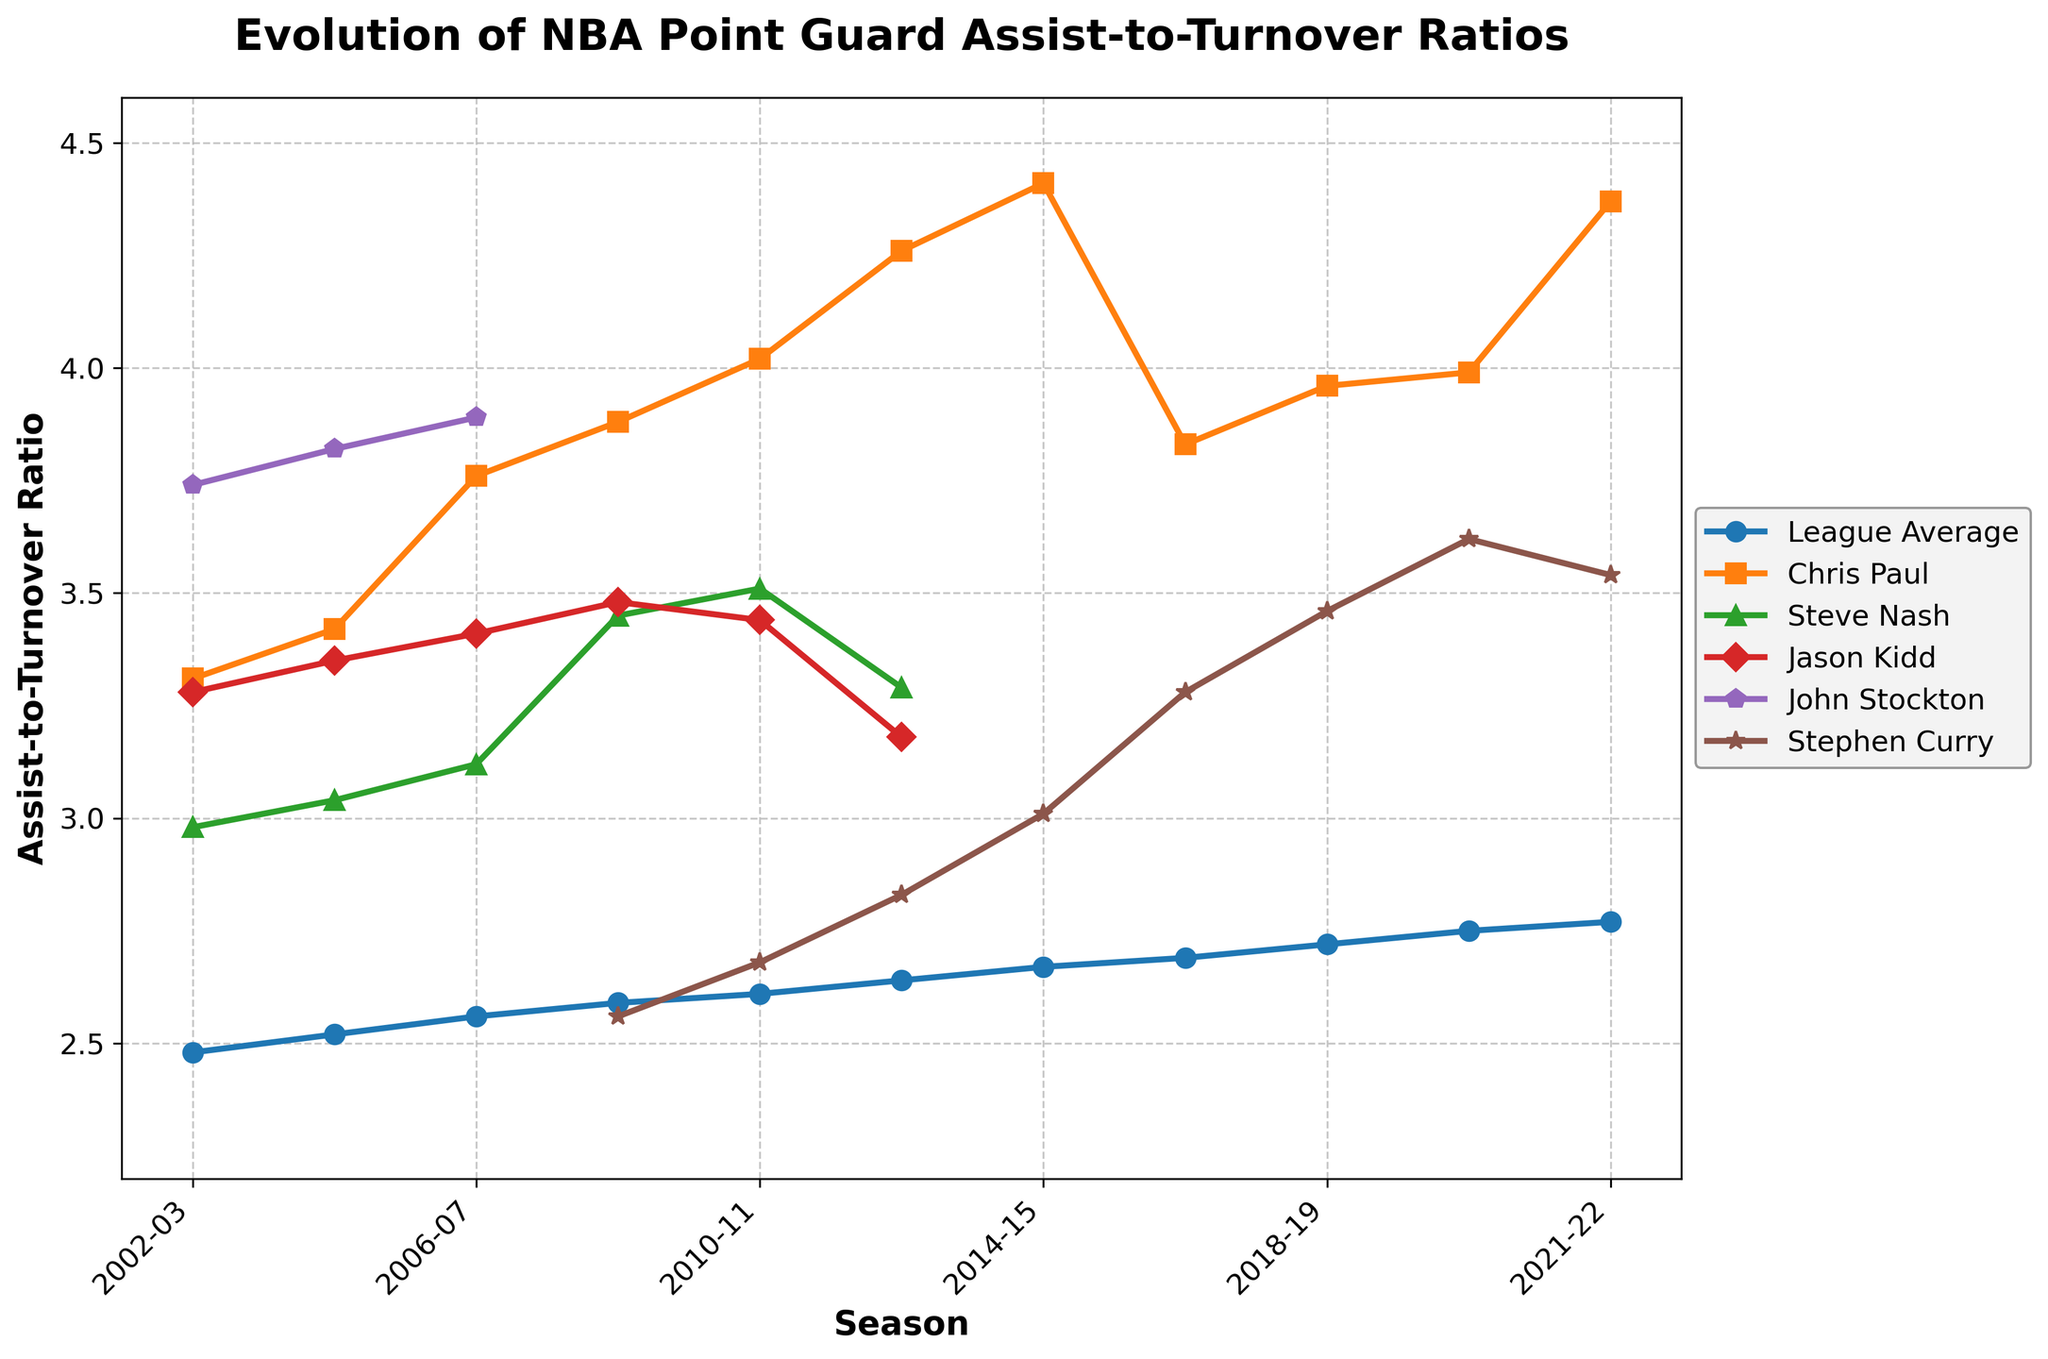What's the average assist-to-turnover ratio for Chris Paul from 2002-03 to 2021-22? The seasons for Chris Paul's data range from 2002-03 to 2021-22. Sum up the assist-to-turnover ratios for these seasons: (3.31 + 3.42 + 3.76 + 3.88 + 4.02 + 4.26 + 4.41 + 3.83 + 3.96 + 3.99 + 4.37) = 43.21. Divide by the number of seasons (11). The average is 43.21/11 = 3.93
Answer: 3.93 Who had the highest assist-to-turnover ratio in the 2006-07 season? In the 2006-07 season, the assist-to-turnover ratios are as follows: League Average: 2.56, Chris Paul: 3.76, Steve Nash: 3.12, Jason Kidd: 3.41, John Stockton: 3.89. The highest value is 3.89 by John Stockton.
Answer: John Stockton How much did the league average assist-to-turnover ratio increase from 2002-03 to 2021-22? Subtract the value for 2002-03 (2.48) from the value for 2021-22 (2.77). The increase is 2.77 - 2.48 = 0.29
Answer: 0.29 In the 2016-17 season, whose assist-to-turnover ratio was closest to the league average? In the 2016-17 season, the league average is 2.69. Comparing the values: Chris Paul (3.83), Stephen Curry (3.28). The closest value to 2.69 is 3.28 by Stephen Curry.
Answer: Stephen Curry What is the highest assist-to-turnover ratio recorded by a player over the periods shown? The highest recorded value in the data provided is Chris Paul's 4.41 in the 2014-15 season.
Answer: 4.41 Whose assist-to-turnover ratios were both higher than the league average in the 2002-03 season? For 2002-03, compare the league average (2.48) to other values: Chris Paul (3.31), Steve Nash (2.98), Jason Kidd (3.28), John Stockton (3.74). The persons whose ratios were higher than the league average are Chris Paul, Steve Nash, Jason Kidd, and John Stockton.
Answer: Chris Paul, Steve Nash, Jason Kidd, John Stockton Between which consecutive seasons did Chris Paul’s assist-to-turnover ratio see the largest increase? To identify the largest increase, calculate the differences between consecutive seasons: 2004-03 to 2004-05 (3.42 - 3.31 = 0.11), 2004-05 to 2006-07 (3.76 - 3.42 = 0.34), 2006-07 to 2008-09 (3.88 - 3.76 = 0.12), 2008-09 to 2010-11 (4.02 - 3.88 = 0.14), 2010-11 to 2012-13 (4.26 - 4.02 = 0.24), etc. The largest increase is between 2004-05 and 2006-07 (0.34).
Answer: 2004-05 to 2006-07 Did Stephen Curry's assist-to-turnover ratio ever surpass the league average stated for each of his seasons in the data? Compare Stephen Curry’s values to the corresponding league averages in his seasons: 2008-09 (2.56 vs 2.59), 2010-11 (2.68 vs 2.61), 2012-13 (2.83 vs 2.64), 2014-15 (3.01 vs 2.67), 2016-17 (3.28 vs 2.69), 2018-19 (3.46 vs 2.72), 2020-21 (3.62 vs 2.75), 2021-22 (3.54 vs 2.77). He surpassed the league average in 2010-11, 2020-21, and 2021-22.
Answer: Yes Which player showed the most consistent assist-to-turnover ratio over the seasons they are shown? Consistency can be observed by smaller variations in the values. Measure the standard deviation (variation) of the assist-to-turnover ratios: Chris Paul (range from 3.31 to 4.41), Steve Nash (range from 2.98 to 3.51), Jason Kidd (range from 3.28 to 3.48), John Stockton (range from 3.74 to 3.89), Stephen Curry (range from 2.56 to 3.62). With the least range, John Stockton is the most consistent (3.74 to 3.89).
Answer: John Stockton 